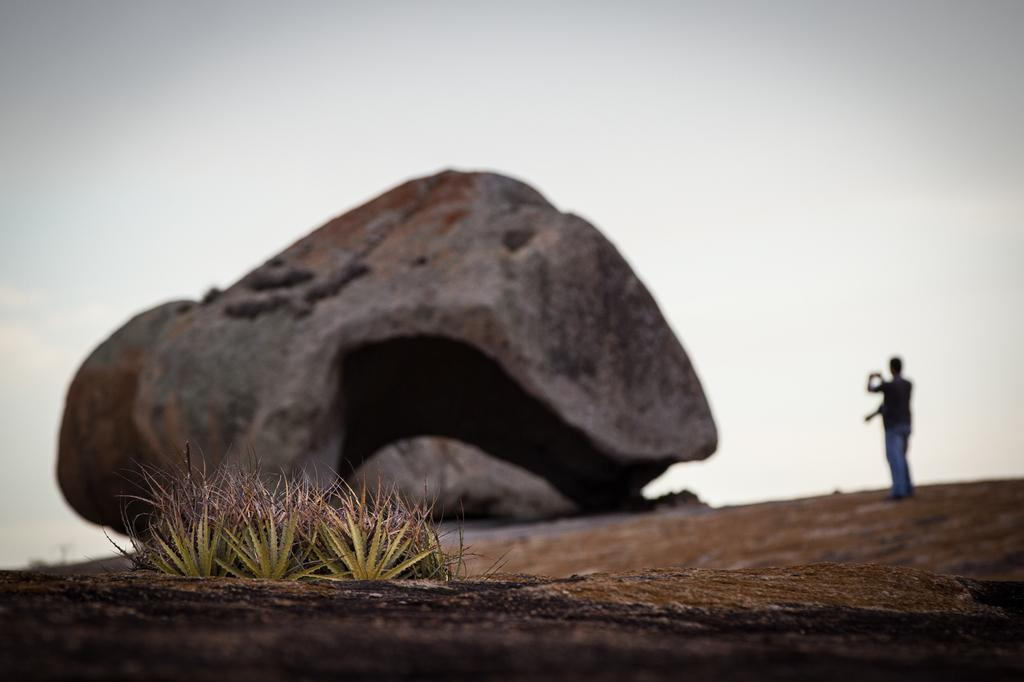What is the main object in the image? There is a rock in the image. How many people are present in the image? There are two persons standing in the image. What are the persons holding in the image? The persons are holding an object. What can be seen in the background of the image? There is sky visible in the image. What type of vegetation is present in the image? There are plants in the image. What type of bike can be seen in the image? There is no bike present in the image. Can you tell me what the locket around the person's neck looks like? There is no locket visible in the image. 